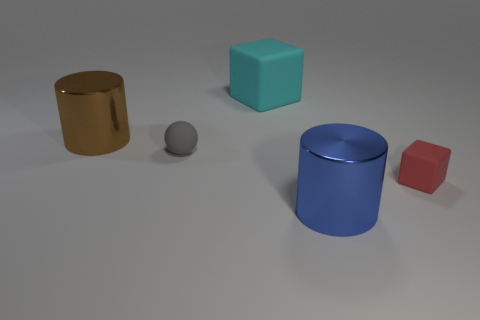Subtract all brown balls. Subtract all gray cylinders. How many balls are left? 1 Add 3 small green matte cubes. How many objects exist? 8 Subtract all balls. How many objects are left? 4 Add 1 large shiny objects. How many large shiny objects exist? 3 Subtract 1 blue cylinders. How many objects are left? 4 Subtract all gray balls. Subtract all blue metallic cylinders. How many objects are left? 3 Add 2 large blue cylinders. How many large blue cylinders are left? 3 